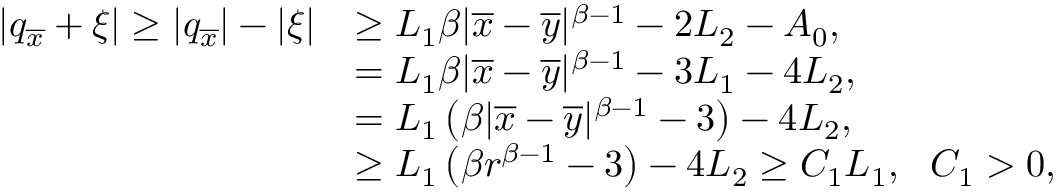Convert formula to latex. <formula><loc_0><loc_0><loc_500><loc_500>\begin{array} { r l } { | q _ { \overline { x } } + \xi | \geq | q _ { \overline { x } } | - | \xi | } & { \geq L _ { 1 } \beta | \overline { x } - \overline { y } | ^ { \beta - 1 } - 2 L _ { 2 } - A _ { 0 } , } \\ & { = L _ { 1 } \beta | \overline { x } - \overline { y } | ^ { \beta - 1 } - 3 L _ { 1 } - 4 L _ { 2 } , } \\ & { = L _ { 1 } \left ( \beta | \overline { x } - \overline { y } | ^ { \beta - 1 } - 3 \right ) - 4 L _ { 2 } , } \\ & { \geq L _ { 1 } \left ( \beta r ^ { \beta - 1 } - 3 \right ) - 4 L _ { 2 } \geq C _ { 1 } L _ { 1 } , \ \ C _ { 1 } > 0 , } \end{array}</formula> 